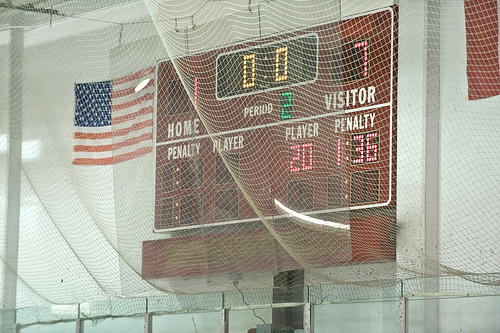<image>
Can you confirm if the flag is to the right of the scoreboard? No. The flag is not to the right of the scoreboard. The horizontal positioning shows a different relationship. 